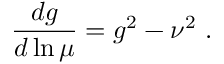<formula> <loc_0><loc_0><loc_500><loc_500>{ \frac { d g } { d \ln \mu } } = g ^ { 2 } - \nu ^ { 2 } .</formula> 